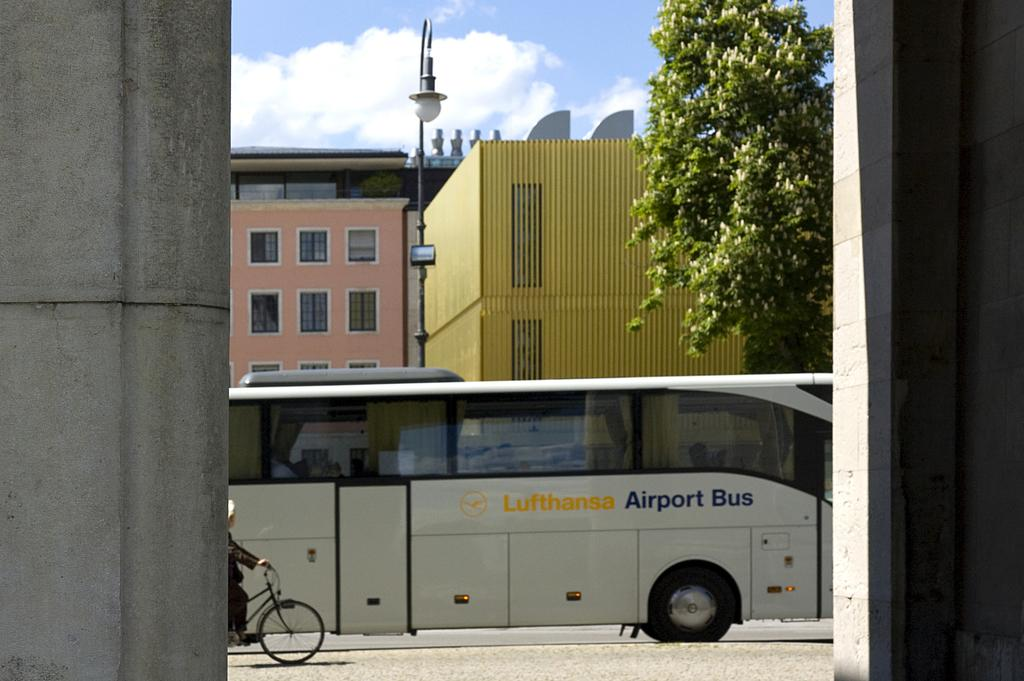What mode of transportation can be seen on the road in the image? There is a bus on a road in the image. What activity is being performed by a person in the image? There is a person cycling in the image. What can be seen in the background of the image? There are buildings, trees, and the sky visible in the background of the image. What architectural features are present on the sides of the image? There are pillars on the right side and left side of the image. What type of drug is being sold by the person cycling in the image? There is no indication of any drug being sold or present in the image. What memory is being triggered by the presence of the bus in the image? The image does not depict any specific memory being triggered by the presence of the bus. 